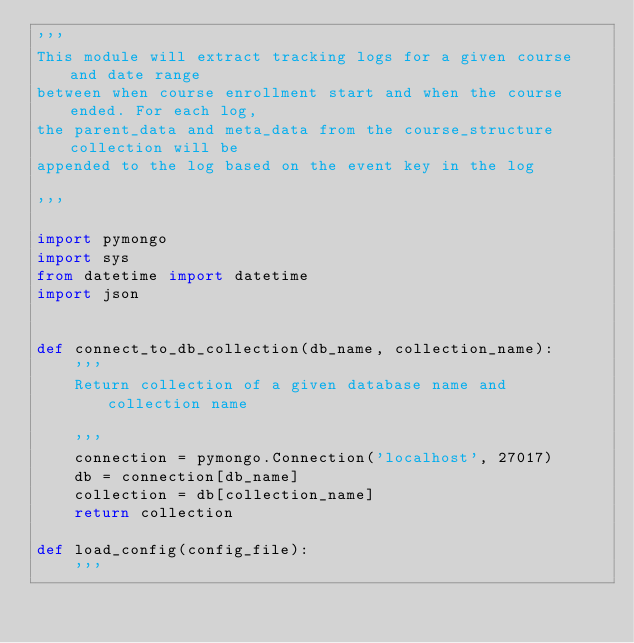Convert code to text. <code><loc_0><loc_0><loc_500><loc_500><_Python_>'''
This module will extract tracking logs for a given course and date range 
between when course enrollment start and when the course ended. For each log,
the parent_data and meta_data from the course_structure collection will be 
appended to the log based on the event key in the log

'''

import pymongo
import sys
from datetime import datetime
import json


def connect_to_db_collection(db_name, collection_name):
    '''
    Return collection of a given database name and collection name
    
    '''
    connection = pymongo.Connection('localhost', 27017)
    db = connection[db_name]
    collection = db[collection_name]
    return collection 

def load_config(config_file):
    '''</code> 